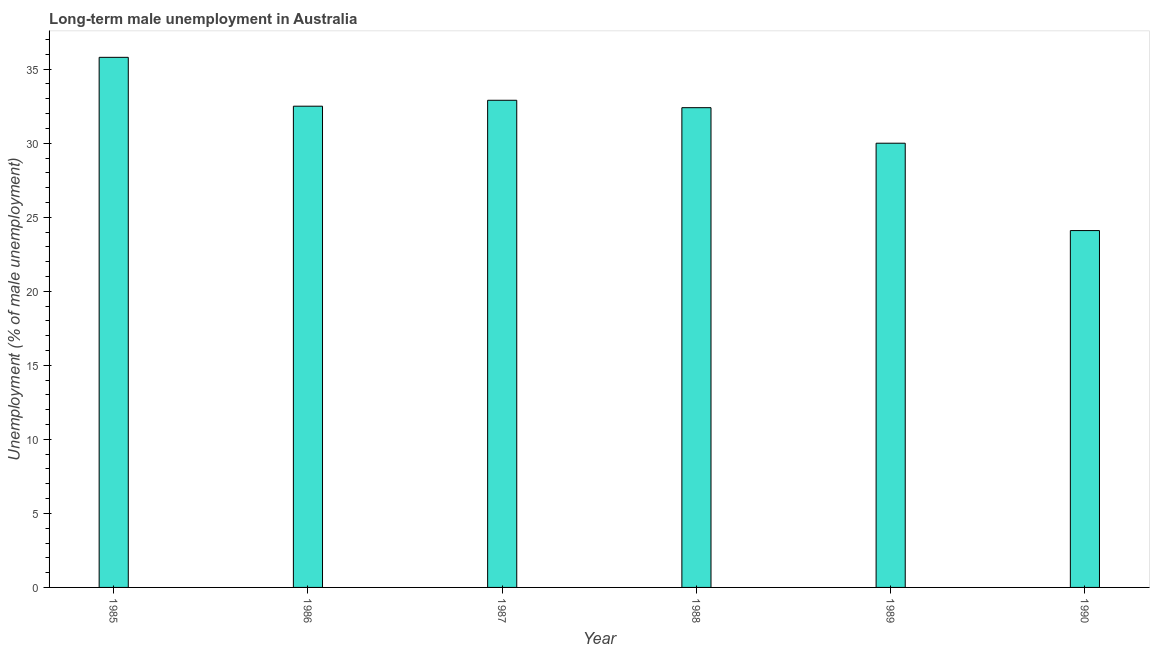Does the graph contain any zero values?
Provide a succinct answer. No. What is the title of the graph?
Give a very brief answer. Long-term male unemployment in Australia. What is the label or title of the Y-axis?
Keep it short and to the point. Unemployment (% of male unemployment). What is the long-term male unemployment in 1985?
Give a very brief answer. 35.8. Across all years, what is the maximum long-term male unemployment?
Keep it short and to the point. 35.8. Across all years, what is the minimum long-term male unemployment?
Offer a very short reply. 24.1. In which year was the long-term male unemployment maximum?
Ensure brevity in your answer.  1985. In which year was the long-term male unemployment minimum?
Your answer should be very brief. 1990. What is the sum of the long-term male unemployment?
Your answer should be compact. 187.7. What is the average long-term male unemployment per year?
Your answer should be very brief. 31.28. What is the median long-term male unemployment?
Offer a terse response. 32.45. What is the ratio of the long-term male unemployment in 1989 to that in 1990?
Keep it short and to the point. 1.25. In how many years, is the long-term male unemployment greater than the average long-term male unemployment taken over all years?
Provide a succinct answer. 4. How many bars are there?
Your answer should be compact. 6. Are all the bars in the graph horizontal?
Provide a succinct answer. No. How many years are there in the graph?
Your answer should be very brief. 6. What is the difference between two consecutive major ticks on the Y-axis?
Your answer should be very brief. 5. Are the values on the major ticks of Y-axis written in scientific E-notation?
Your response must be concise. No. What is the Unemployment (% of male unemployment) of 1985?
Offer a terse response. 35.8. What is the Unemployment (% of male unemployment) in 1986?
Your answer should be very brief. 32.5. What is the Unemployment (% of male unemployment) of 1987?
Your answer should be compact. 32.9. What is the Unemployment (% of male unemployment) of 1988?
Offer a terse response. 32.4. What is the Unemployment (% of male unemployment) in 1990?
Provide a short and direct response. 24.1. What is the difference between the Unemployment (% of male unemployment) in 1985 and 1990?
Ensure brevity in your answer.  11.7. What is the difference between the Unemployment (% of male unemployment) in 1986 and 1989?
Offer a very short reply. 2.5. What is the difference between the Unemployment (% of male unemployment) in 1987 and 1988?
Keep it short and to the point. 0.5. What is the difference between the Unemployment (% of male unemployment) in 1987 and 1990?
Offer a very short reply. 8.8. What is the ratio of the Unemployment (% of male unemployment) in 1985 to that in 1986?
Provide a short and direct response. 1.1. What is the ratio of the Unemployment (% of male unemployment) in 1985 to that in 1987?
Your answer should be compact. 1.09. What is the ratio of the Unemployment (% of male unemployment) in 1985 to that in 1988?
Provide a succinct answer. 1.1. What is the ratio of the Unemployment (% of male unemployment) in 1985 to that in 1989?
Offer a very short reply. 1.19. What is the ratio of the Unemployment (% of male unemployment) in 1985 to that in 1990?
Provide a succinct answer. 1.49. What is the ratio of the Unemployment (% of male unemployment) in 1986 to that in 1987?
Ensure brevity in your answer.  0.99. What is the ratio of the Unemployment (% of male unemployment) in 1986 to that in 1988?
Offer a terse response. 1. What is the ratio of the Unemployment (% of male unemployment) in 1986 to that in 1989?
Provide a succinct answer. 1.08. What is the ratio of the Unemployment (% of male unemployment) in 1986 to that in 1990?
Make the answer very short. 1.35. What is the ratio of the Unemployment (% of male unemployment) in 1987 to that in 1988?
Your answer should be very brief. 1.01. What is the ratio of the Unemployment (% of male unemployment) in 1987 to that in 1989?
Ensure brevity in your answer.  1.1. What is the ratio of the Unemployment (% of male unemployment) in 1987 to that in 1990?
Make the answer very short. 1.36. What is the ratio of the Unemployment (% of male unemployment) in 1988 to that in 1990?
Keep it short and to the point. 1.34. What is the ratio of the Unemployment (% of male unemployment) in 1989 to that in 1990?
Your answer should be compact. 1.25. 